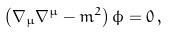<formula> <loc_0><loc_0><loc_500><loc_500>\left ( \nabla _ { \mu } \nabla ^ { \mu } - m ^ { 2 } \right ) \phi = 0 \, ,</formula> 